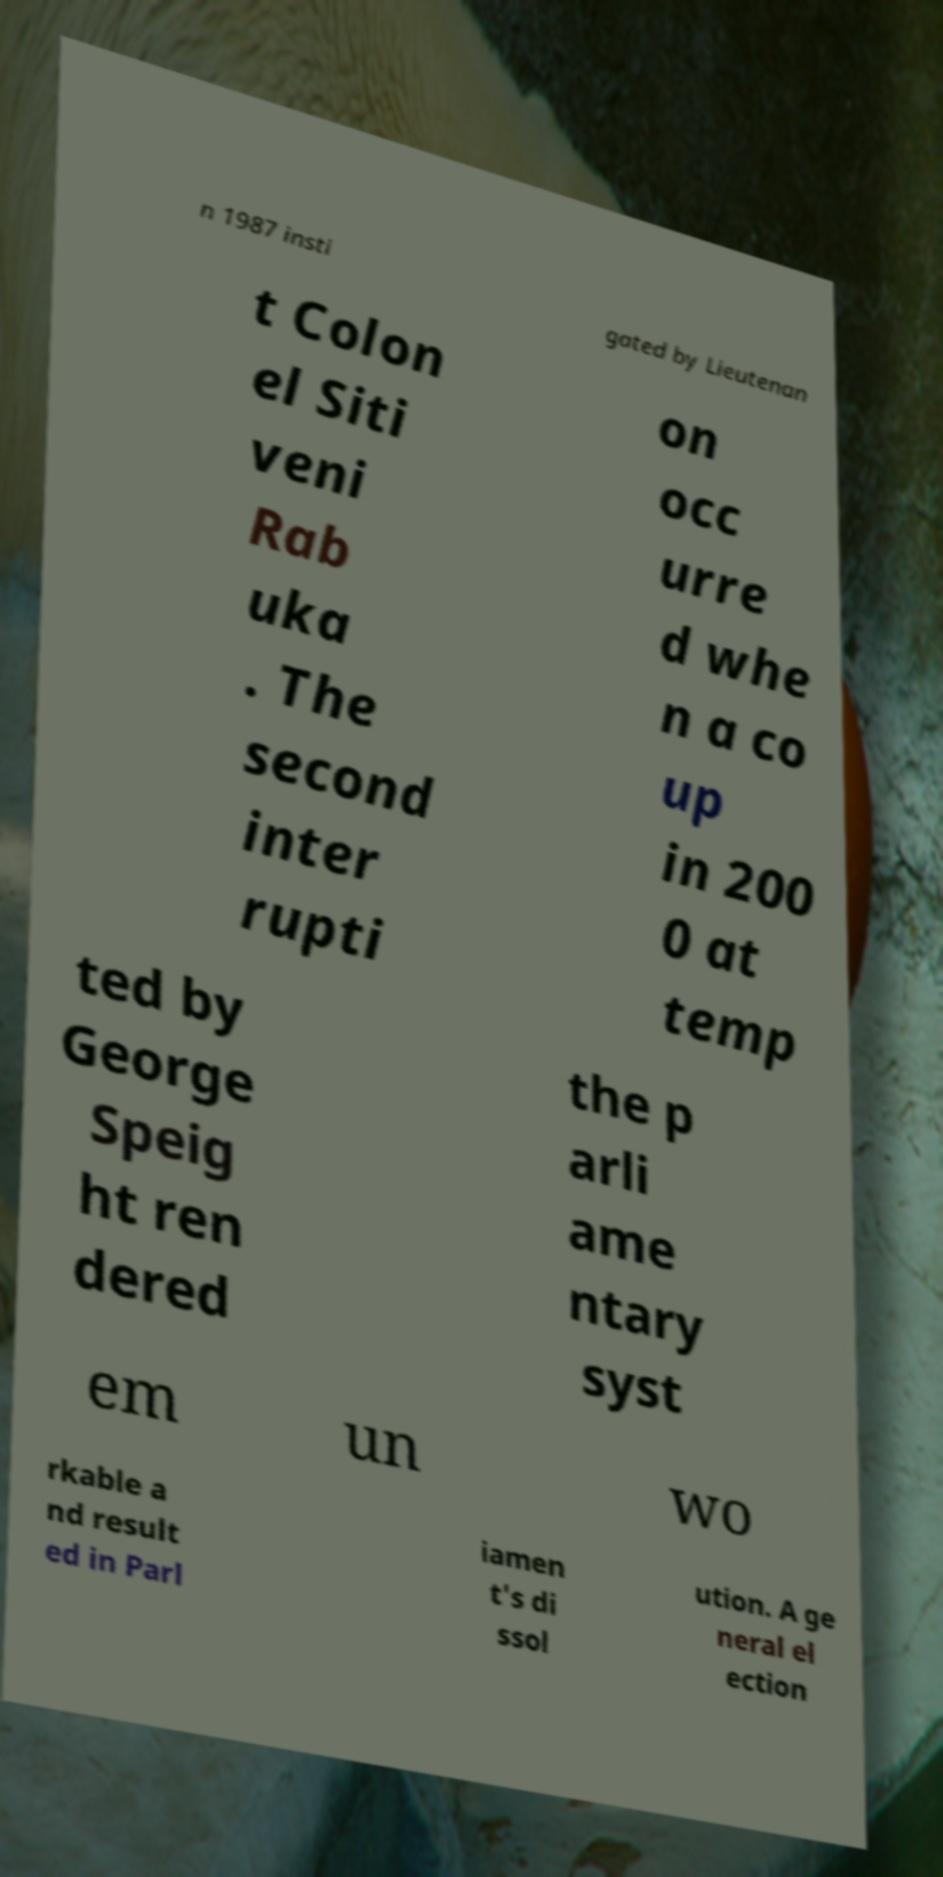Can you read and provide the text displayed in the image?This photo seems to have some interesting text. Can you extract and type it out for me? n 1987 insti gated by Lieutenan t Colon el Siti veni Rab uka . The second inter rupti on occ urre d whe n a co up in 200 0 at temp ted by George Speig ht ren dered the p arli ame ntary syst em un wo rkable a nd result ed in Parl iamen t's di ssol ution. A ge neral el ection 